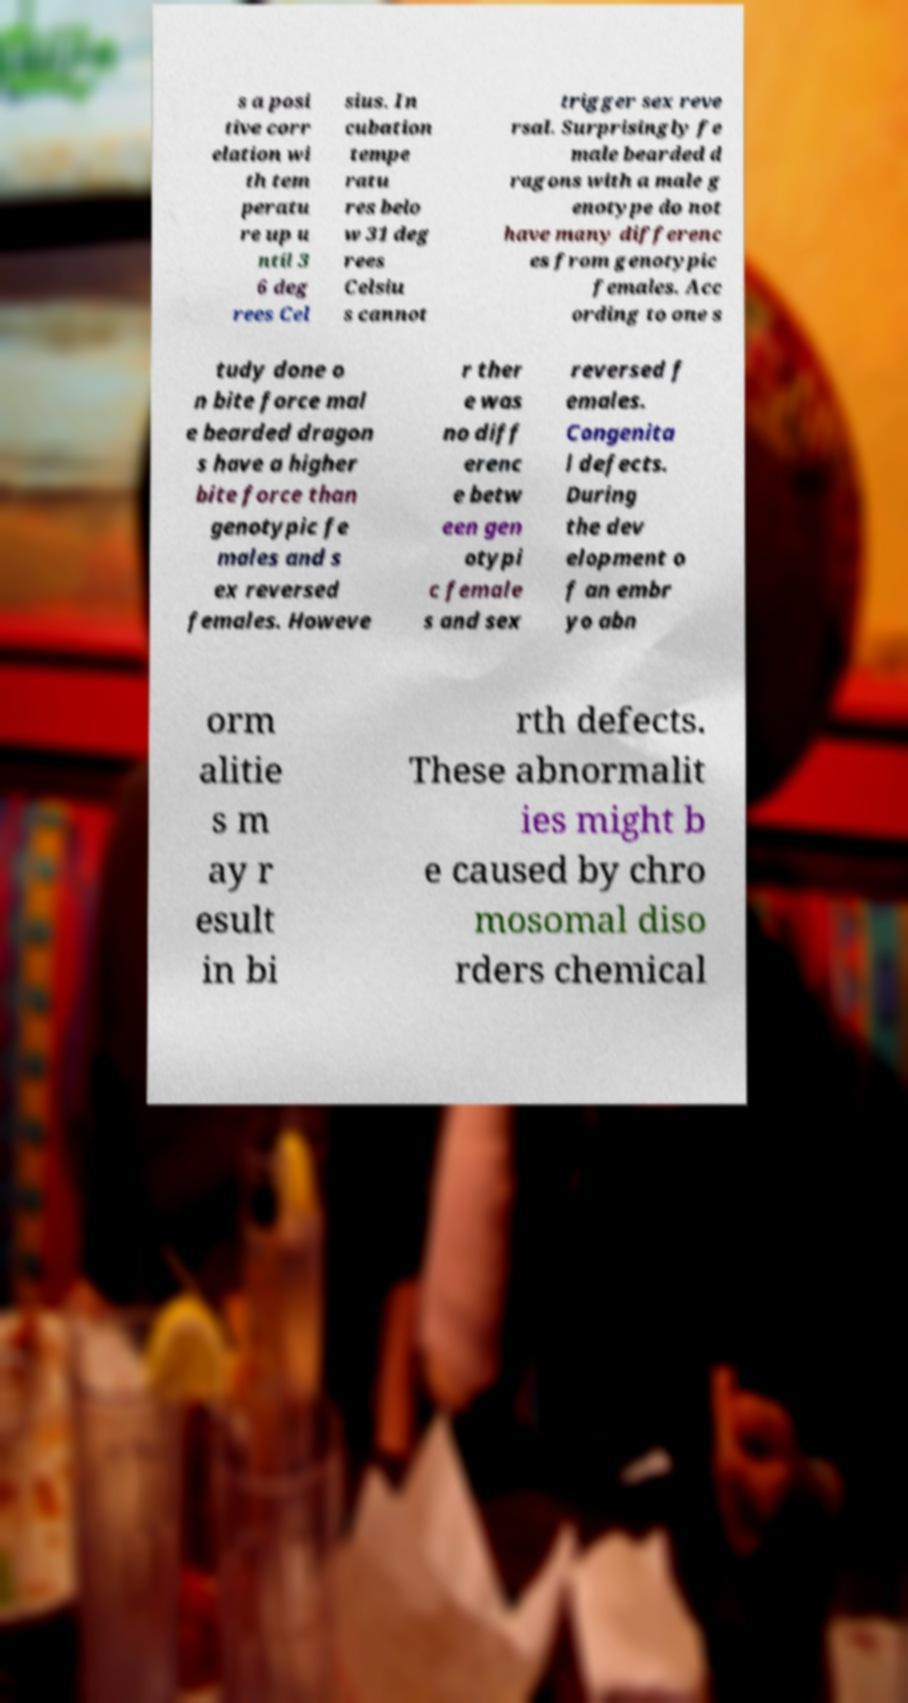Please identify and transcribe the text found in this image. s a posi tive corr elation wi th tem peratu re up u ntil 3 6 deg rees Cel sius. In cubation tempe ratu res belo w 31 deg rees Celsiu s cannot trigger sex reve rsal. Surprisingly fe male bearded d ragons with a male g enotype do not have many differenc es from genotypic females. Acc ording to one s tudy done o n bite force mal e bearded dragon s have a higher bite force than genotypic fe males and s ex reversed females. Howeve r ther e was no diff erenc e betw een gen otypi c female s and sex reversed f emales. Congenita l defects. During the dev elopment o f an embr yo abn orm alitie s m ay r esult in bi rth defects. These abnormalit ies might b e caused by chro mosomal diso rders chemical 